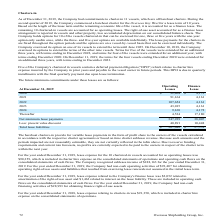According to Overseas Shipholding Group's financial document, How much was the lease expense relating to charters-in for the year ended December 31, 2018? According to the financial document, $91,350. The relevant text states: "1, 2018, lease expense relating to charters-in was $91,350, which is included in charter hire expense on the consolidated statements of operations...." Also, can you calculate: What is the change in future minimum commitments of Operating Leases from 2020 to 2021? Based on the calculation: 91,164-92,404, the result is -1240. This is based on the information: "2020 $ 92,404 $ 4,172 2021 91,164 4,161..." The key data points involved are: 91,164, 92,404. Also, can you calculate: What is the average future minimum commitments of Operating Leases for 2020 to 2021? To answer this question, I need to perform calculations using the financial data. The calculation is: (91,164+92,404) / 2, which equals 91784. This is based on the information: "2020 $ 92,404 $ 4,172 2021 91,164 4,161..." The key data points involved are: 91,164, 92,404. Additionally, In which year was Operating Leases greater than 100,000? According to the financial document, 2022. The relevant text states: "2022 107,654 4,161..." Also, What was the Finance Lease in 2020 and 2021 respectively? The document shows two values: $4,172 and 4,161. From the document: "2020 $ 92,404 $ 4,172 2021 91,164 4,161..." Also, What was the Finance Lease in 2022 and 2023 respectively? The document shows two values: 4,161 and 4,161. From the document: "2021 91,164 4,161..." 